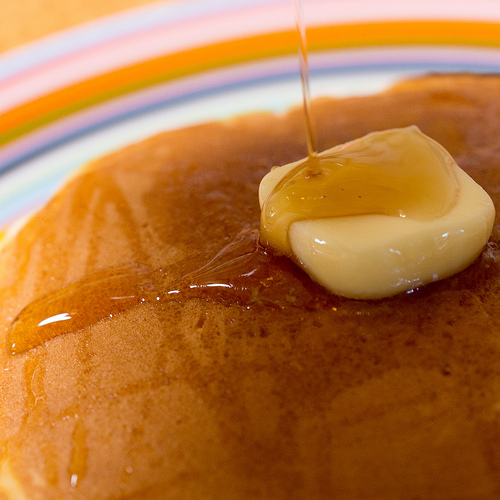<image>
Is there a pancake under the butter? Yes. The pancake is positioned underneath the butter, with the butter above it in the vertical space. Is there a syrup above the butter? Yes. The syrup is positioned above the butter in the vertical space, higher up in the scene. 